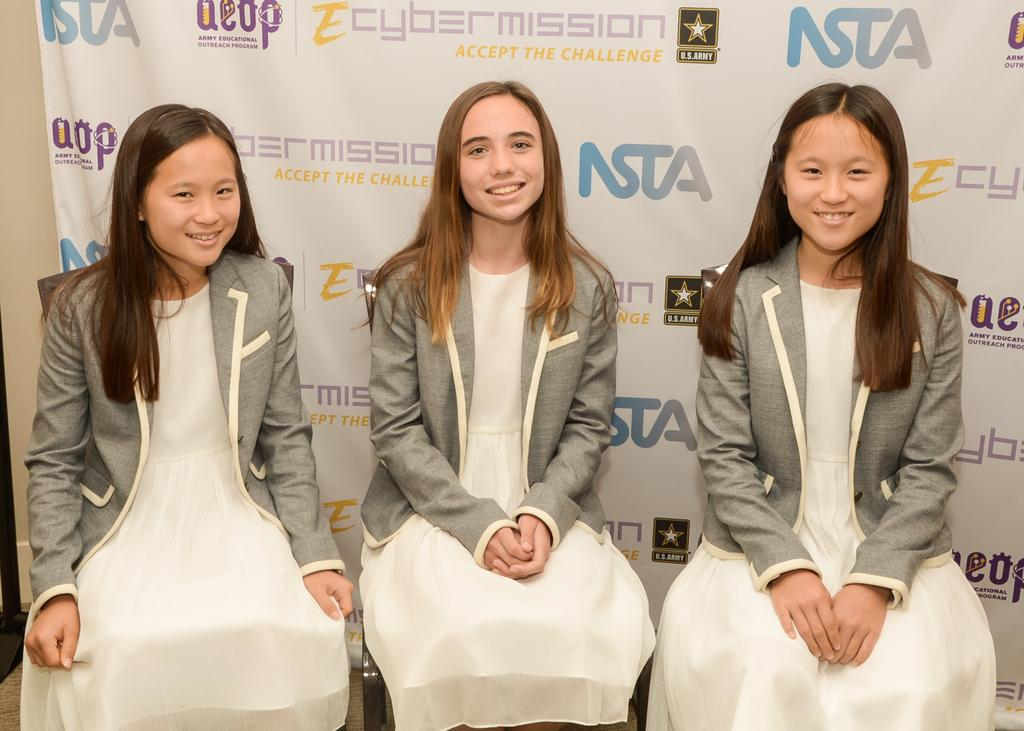What are the girls in the image doing? The girls in the image are sitting on chairs. What are the girls wearing on their upper bodies? The girls are wearing ash-colored jackets. What are the girls wearing on their lower bodies? The girls are wearing white-colored frocks. What can be seen hanging or displayed in the image? There is a banner visible in the image. What type of pest can be seen crawling on the girls' chairs in the image? There are no pests visible in the image; it only shows the girls sitting on chairs. 